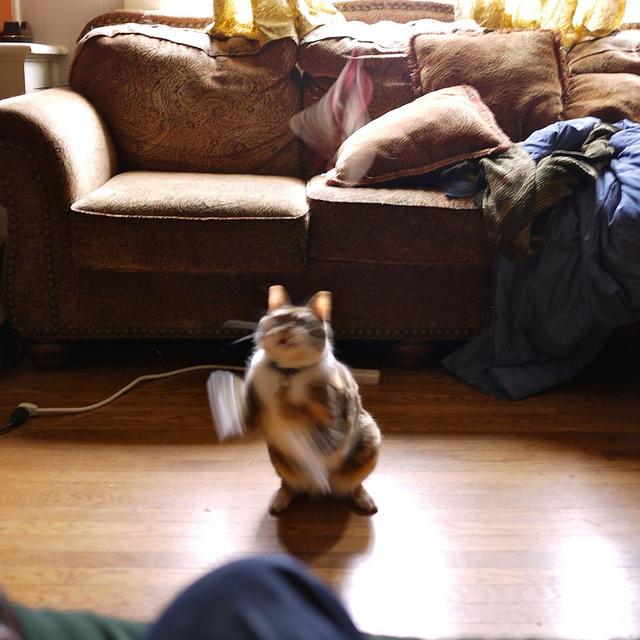What is on the couch?
Give a very brief answer. Pillows. What animal is on the floor?
Short answer required. Cat. Is the floor reflective?
Keep it brief. Yes. 